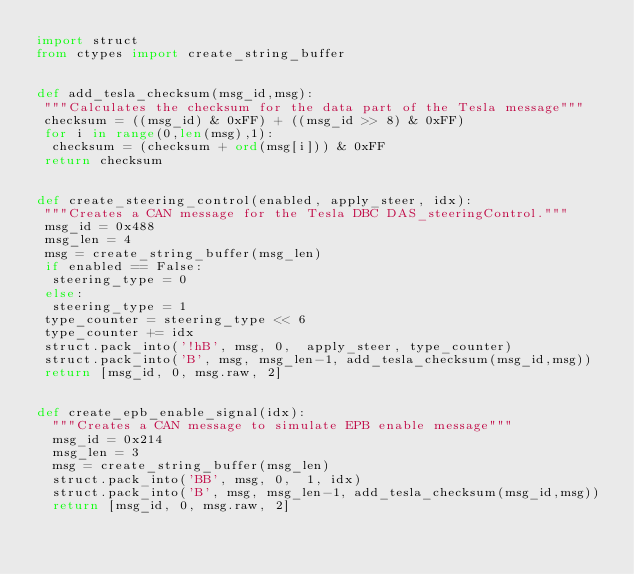Convert code to text. <code><loc_0><loc_0><loc_500><loc_500><_Python_>import struct
from ctypes import create_string_buffer


def add_tesla_checksum(msg_id,msg):
 """Calculates the checksum for the data part of the Tesla message"""
 checksum = ((msg_id) & 0xFF) + ((msg_id >> 8) & 0xFF)
 for i in range(0,len(msg),1):
  checksum = (checksum + ord(msg[i])) & 0xFF
 return checksum


def create_steering_control(enabled, apply_steer, idx):
 """Creates a CAN message for the Tesla DBC DAS_steeringControl."""
 msg_id = 0x488
 msg_len = 4
 msg = create_string_buffer(msg_len)
 if enabled == False:
  steering_type = 0
 else:
  steering_type = 1
 type_counter = steering_type << 6
 type_counter += idx
 struct.pack_into('!hB', msg, 0,  apply_steer, type_counter)
 struct.pack_into('B', msg, msg_len-1, add_tesla_checksum(msg_id,msg))
 return [msg_id, 0, msg.raw, 2]


def create_epb_enable_signal(idx):
  """Creates a CAN message to simulate EPB enable message"""
  msg_id = 0x214
  msg_len = 3
  msg = create_string_buffer(msg_len)
  struct.pack_into('BB', msg, 0,  1, idx)
  struct.pack_into('B', msg, msg_len-1, add_tesla_checksum(msg_id,msg))
  return [msg_id, 0, msg.raw, 2]
  
</code> 